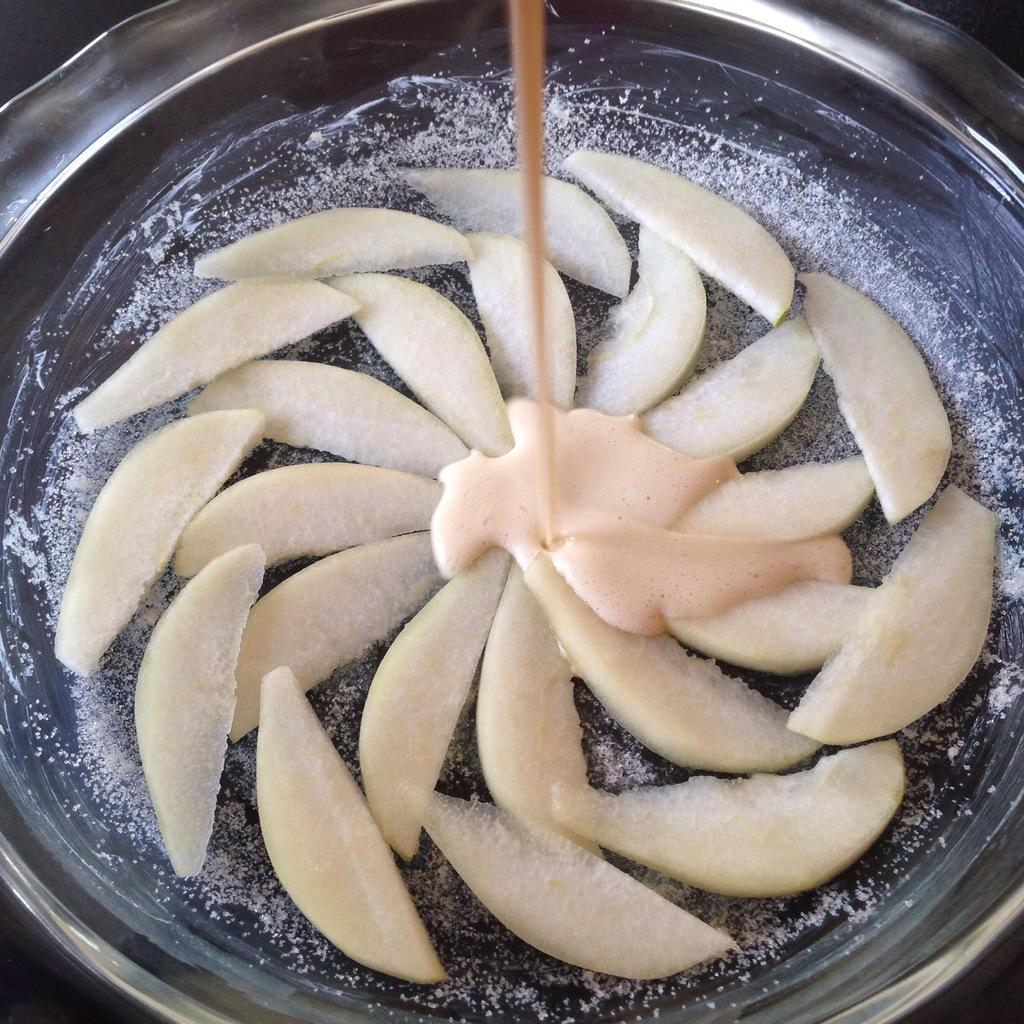What is the main subject in the image? There is a food item in a pan in the image. Where is the nearest playground to the food item in the image? There is no information about a playground or its location in the image. Is there a bomb hidden in the pan with the food item? There is no mention of a bomb or any hidden objects in the image. 